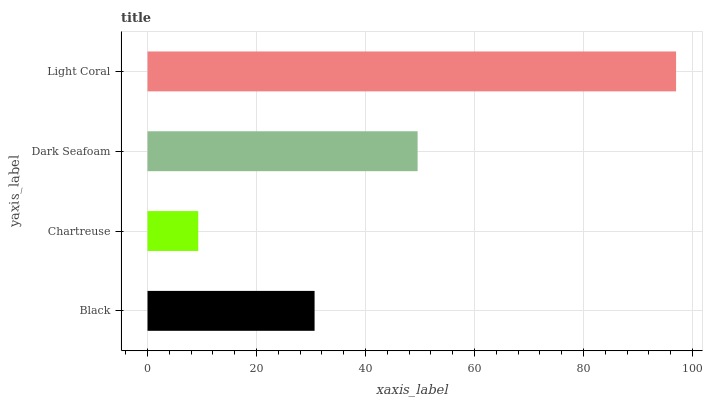Is Chartreuse the minimum?
Answer yes or no. Yes. Is Light Coral the maximum?
Answer yes or no. Yes. Is Dark Seafoam the minimum?
Answer yes or no. No. Is Dark Seafoam the maximum?
Answer yes or no. No. Is Dark Seafoam greater than Chartreuse?
Answer yes or no. Yes. Is Chartreuse less than Dark Seafoam?
Answer yes or no. Yes. Is Chartreuse greater than Dark Seafoam?
Answer yes or no. No. Is Dark Seafoam less than Chartreuse?
Answer yes or no. No. Is Dark Seafoam the high median?
Answer yes or no. Yes. Is Black the low median?
Answer yes or no. Yes. Is Chartreuse the high median?
Answer yes or no. No. Is Chartreuse the low median?
Answer yes or no. No. 